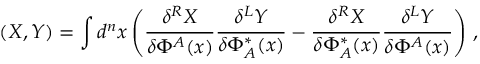<formula> <loc_0><loc_0><loc_500><loc_500>( X , Y ) = \int d ^ { n } x \left ( \frac { \delta ^ { R } X } { \delta \Phi ^ { A } ( x ) } \frac { \delta ^ { L } Y } { \delta \Phi _ { A } ^ { * } ( x ) } - \frac { \delta ^ { R } X } { \delta \Phi _ { A } ^ { * } ( x ) } \frac { \delta ^ { L } Y } { \delta \Phi ^ { A } ( x ) } \right ) \, ,</formula> 